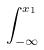<formula> <loc_0><loc_0><loc_500><loc_500>\int _ { - \infty } ^ { x _ { 1 } }</formula> 